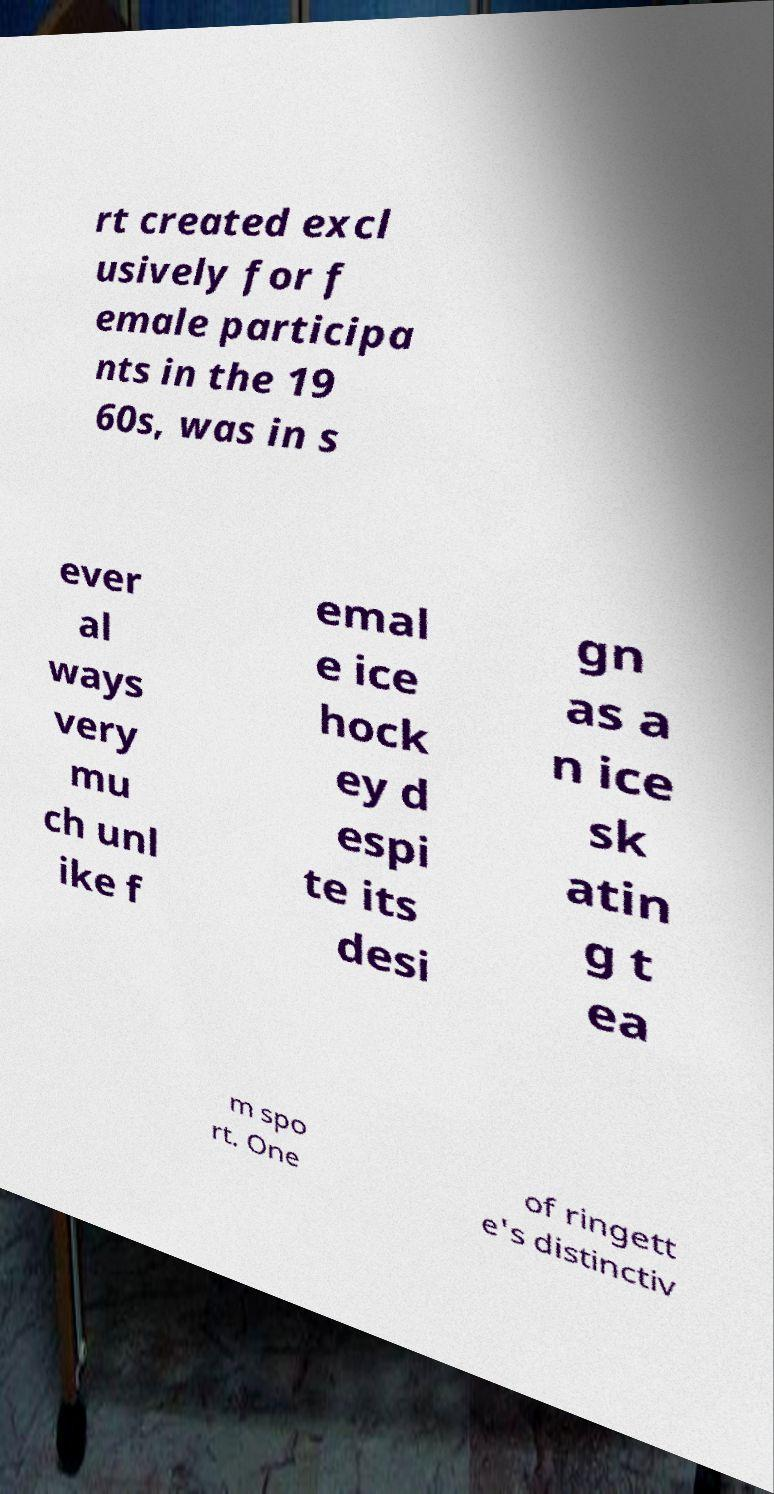Please identify and transcribe the text found in this image. rt created excl usively for f emale participa nts in the 19 60s, was in s ever al ways very mu ch unl ike f emal e ice hock ey d espi te its desi gn as a n ice sk atin g t ea m spo rt. One of ringett e's distinctiv 